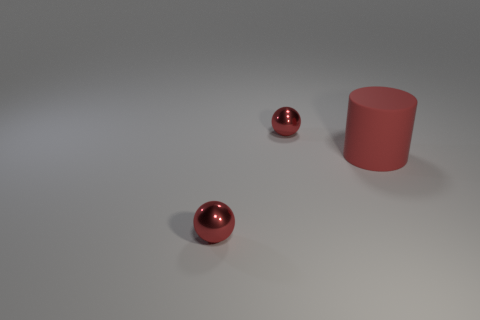There is a sphere in front of the matte object; what is its color?
Provide a succinct answer. Red. How many shiny spheres are behind the small red thing left of the metallic sphere behind the big matte thing?
Ensure brevity in your answer.  1. There is a small shiny thing that is in front of the large matte thing; how many tiny objects are in front of it?
Keep it short and to the point. 0. There is a big rubber cylinder; how many large red cylinders are behind it?
Make the answer very short. 0. What number of other objects are the same size as the matte cylinder?
Make the answer very short. 0. There is a small metallic sphere that is on the right side of the small red shiny sphere that is in front of the big red matte cylinder; what color is it?
Your answer should be very brief. Red. What number of things are red metal spheres behind the big cylinder or large red matte cylinders?
Make the answer very short. 2. Do the matte cylinder and the shiny thing behind the big red matte cylinder have the same size?
Make the answer very short. No. What number of tiny objects are either red rubber cylinders or shiny balls?
Ensure brevity in your answer.  2. Are there any small objects that have the same material as the large thing?
Your answer should be compact. No. 